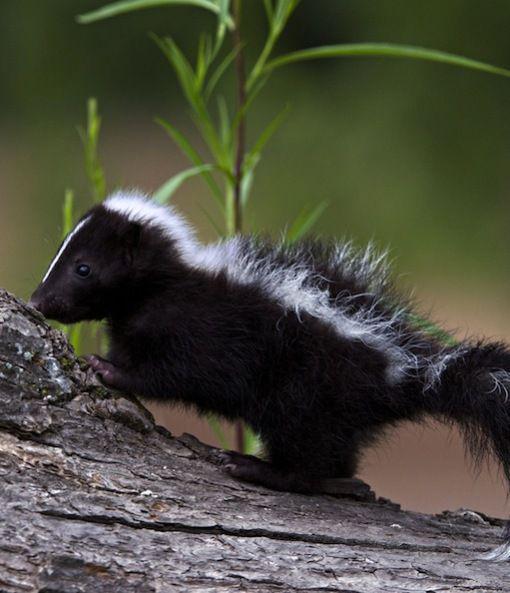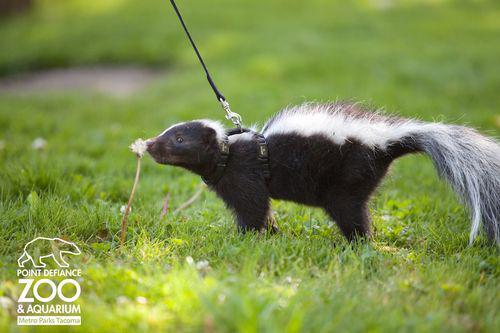The first image is the image on the left, the second image is the image on the right. Evaluate the accuracy of this statement regarding the images: "Two skunks are visible.". Is it true? Answer yes or no. Yes. The first image is the image on the left, the second image is the image on the right. Examine the images to the left and right. Is the description "Left and right images do not contain the same number of skunks, and the left image contains at least one leftward angled skunk with an upright tail." accurate? Answer yes or no. No. 